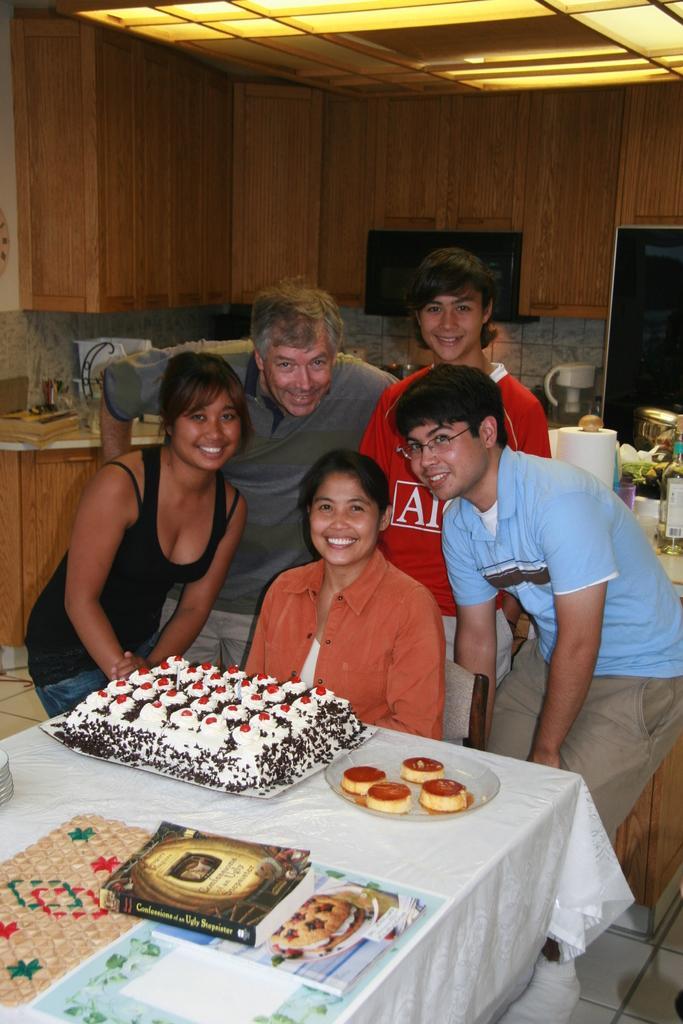Describe this image in one or two sentences. In this picture some people are there in standing position and one woman is sitting on a chair in front of them there is a table on the table we have white color cloth to cover the table and something's is placed on the table they are cake, plate and background we can see the one more table we have tissues and some items are placed on a table 